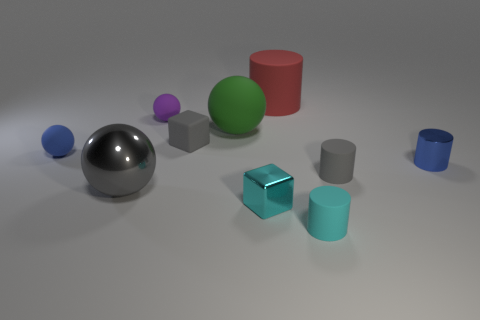Subtract all small purple rubber balls. How many balls are left? 3 Subtract 1 gray blocks. How many objects are left? 9 Subtract all cylinders. How many objects are left? 6 Subtract 4 spheres. How many spheres are left? 0 Subtract all blue balls. Subtract all purple blocks. How many balls are left? 3 Subtract all cyan balls. How many cyan cubes are left? 1 Subtract all matte objects. Subtract all small blue shiny things. How many objects are left? 2 Add 1 gray cylinders. How many gray cylinders are left? 2 Add 7 tiny metal cylinders. How many tiny metal cylinders exist? 8 Subtract all blue cylinders. How many cylinders are left? 3 